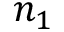Convert formula to latex. <formula><loc_0><loc_0><loc_500><loc_500>n _ { 1 }</formula> 